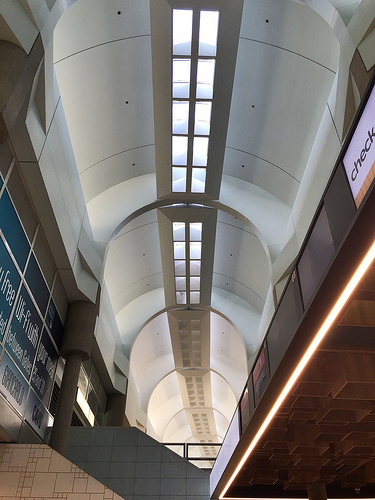<image>
Is the light above the ceiling? No. The light is not positioned above the ceiling. The vertical arrangement shows a different relationship. 